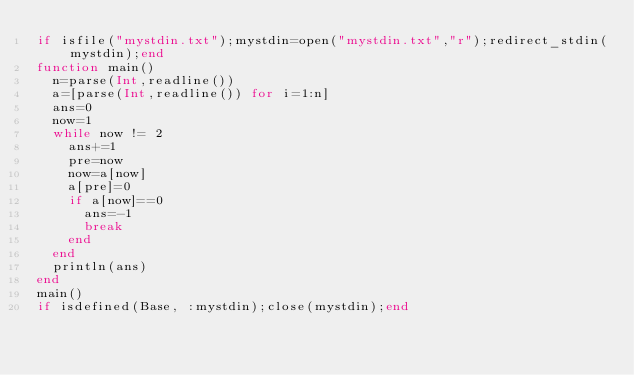<code> <loc_0><loc_0><loc_500><loc_500><_Julia_>if isfile("mystdin.txt");mystdin=open("mystdin.txt","r");redirect_stdin(mystdin);end
function main()
  n=parse(Int,readline())
  a=[parse(Int,readline()) for i=1:n]
  ans=0
  now=1
  while now != 2
    ans+=1
    pre=now
    now=a[now]
    a[pre]=0
    if a[now]==0
      ans=-1
      break
    end
  end
  println(ans)
end
main()
if isdefined(Base, :mystdin);close(mystdin);end</code> 